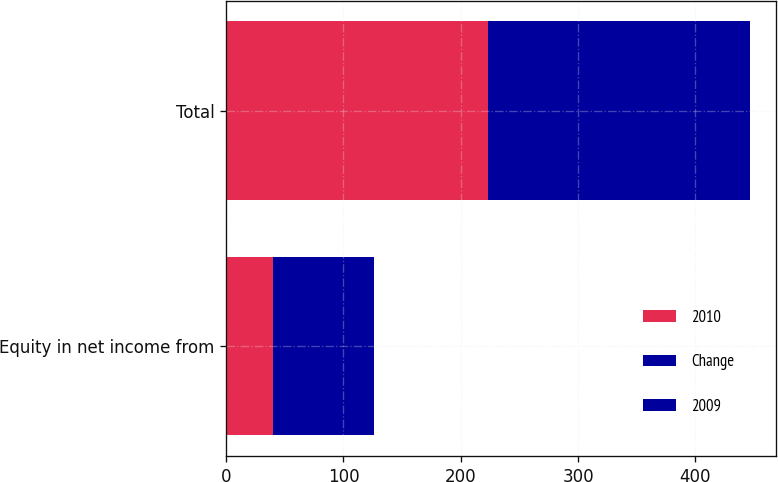Convert chart. <chart><loc_0><loc_0><loc_500><loc_500><stacked_bar_chart><ecel><fcel>Equity in net income from<fcel>Total<nl><fcel>2010<fcel>39.6<fcel>223.2<nl><fcel>Change<fcel>62.9<fcel>175.6<nl><fcel>2009<fcel>23.3<fcel>47.6<nl></chart> 